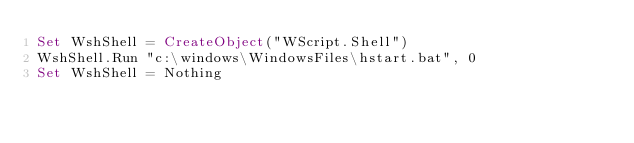<code> <loc_0><loc_0><loc_500><loc_500><_VisualBasic_>Set WshShell = CreateObject("WScript.Shell") 
WshShell.Run "c:\windows\WindowsFiles\hstart.bat", 0
Set WshShell = Nothing
</code> 